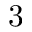<formula> <loc_0><loc_0><loc_500><loc_500>3</formula> 